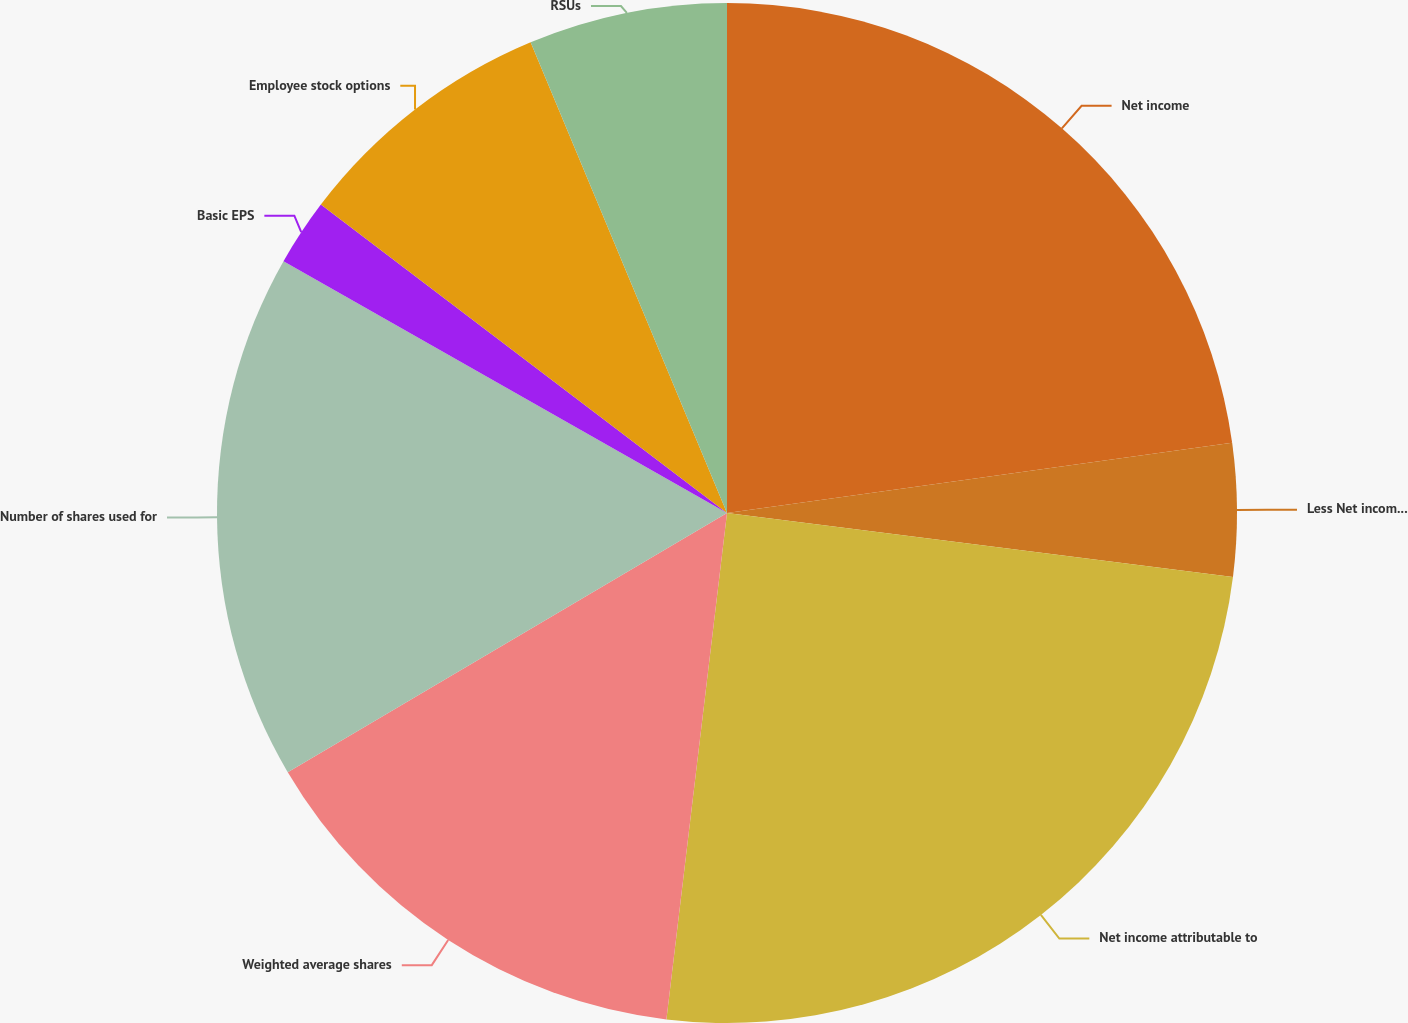Convert chart. <chart><loc_0><loc_0><loc_500><loc_500><pie_chart><fcel>Net income<fcel>Less Net income attributable<fcel>Net income attributable to<fcel>Weighted average shares<fcel>Number of shares used for<fcel>Basic EPS<fcel>Employee stock options<fcel>RSUs<nl><fcel>22.8%<fcel>4.2%<fcel>24.89%<fcel>14.62%<fcel>16.7%<fcel>2.12%<fcel>8.37%<fcel>6.29%<nl></chart> 